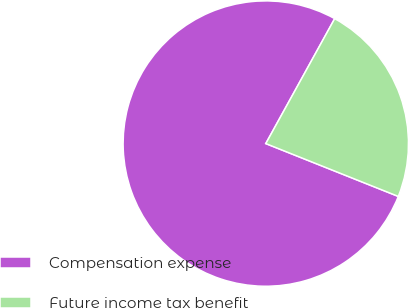Convert chart to OTSL. <chart><loc_0><loc_0><loc_500><loc_500><pie_chart><fcel>Compensation expense<fcel>Future income tax benefit<nl><fcel>76.98%<fcel>23.02%<nl></chart> 